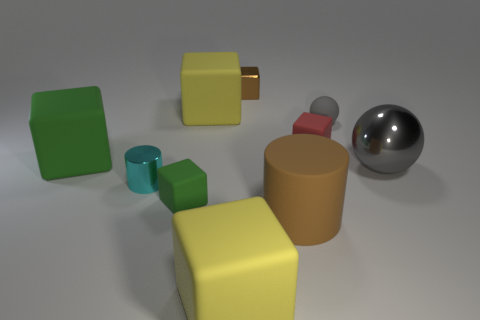Subtract all large yellow rubber blocks. How many blocks are left? 4 Subtract all red cubes. How many cubes are left? 5 Subtract all gray blocks. Subtract all purple balls. How many blocks are left? 6 Subtract all balls. How many objects are left? 8 Add 3 tiny objects. How many tiny objects exist? 8 Subtract 0 purple cylinders. How many objects are left? 10 Subtract all small brown rubber blocks. Subtract all green matte objects. How many objects are left? 8 Add 7 gray things. How many gray things are left? 9 